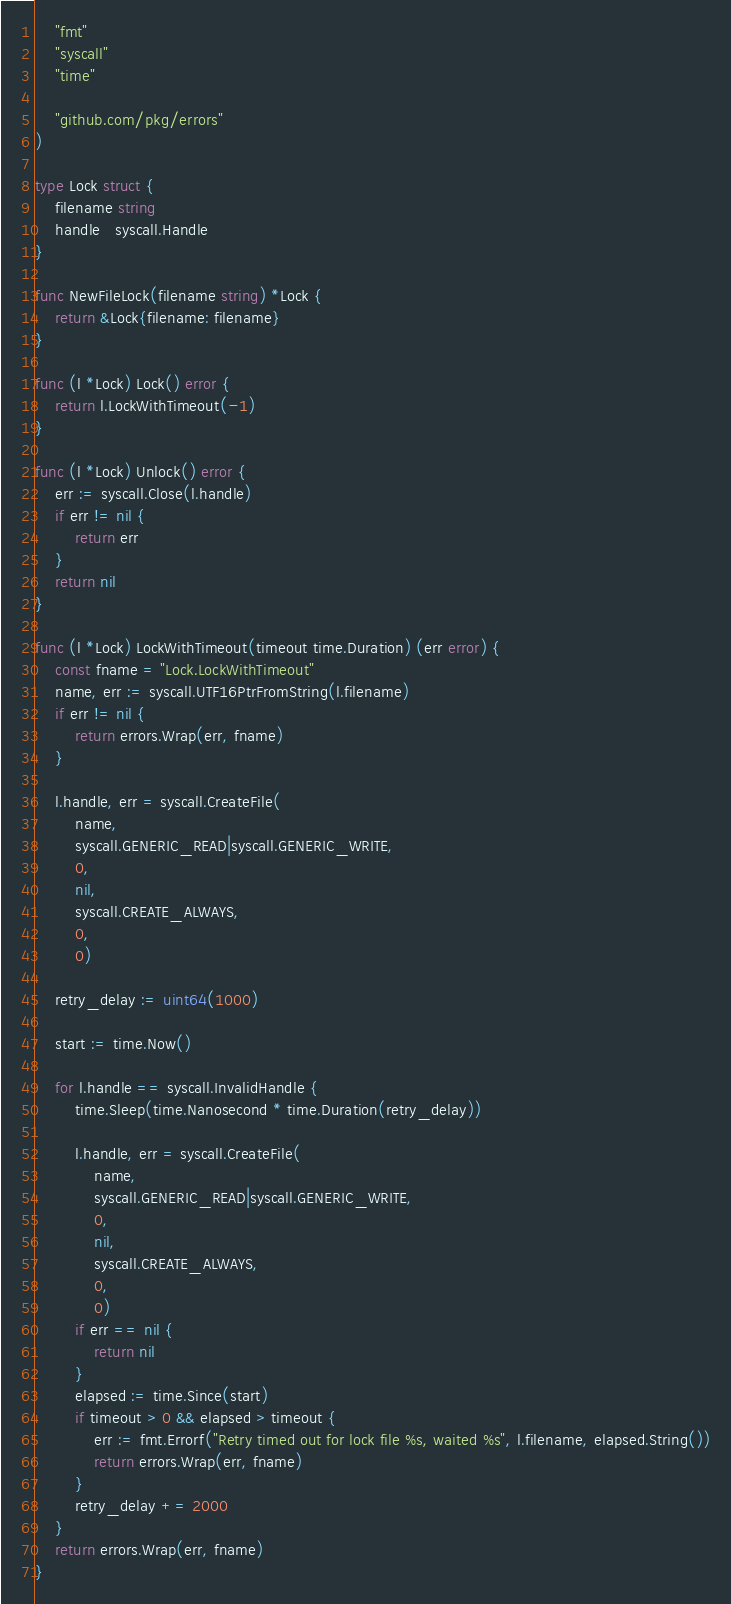<code> <loc_0><loc_0><loc_500><loc_500><_Go_>	"fmt"
	"syscall"
	"time"

	"github.com/pkg/errors"
)

type Lock struct {
	filename string
	handle   syscall.Handle
}

func NewFileLock(filename string) *Lock {
	return &Lock{filename: filename}
}

func (l *Lock) Lock() error {
	return l.LockWithTimeout(-1)
}

func (l *Lock) Unlock() error {
	err := syscall.Close(l.handle)
	if err != nil {
		return err
	}
	return nil
}

func (l *Lock) LockWithTimeout(timeout time.Duration) (err error) {
	const fname = "Lock.LockWithTimeout"
	name, err := syscall.UTF16PtrFromString(l.filename)
	if err != nil {
		return errors.Wrap(err, fname)
	}

	l.handle, err = syscall.CreateFile(
		name,
		syscall.GENERIC_READ|syscall.GENERIC_WRITE,
		0,
		nil,
		syscall.CREATE_ALWAYS,
		0,
		0)

	retry_delay := uint64(1000)

	start := time.Now()

	for l.handle == syscall.InvalidHandle {
		time.Sleep(time.Nanosecond * time.Duration(retry_delay))

		l.handle, err = syscall.CreateFile(
			name,
			syscall.GENERIC_READ|syscall.GENERIC_WRITE,
			0,
			nil,
			syscall.CREATE_ALWAYS,
			0,
			0)
		if err == nil {
			return nil
		}
		elapsed := time.Since(start)
		if timeout > 0 && elapsed > timeout {
			err := fmt.Errorf("Retry timed out for lock file %s, waited %s", l.filename, elapsed.String())
			return errors.Wrap(err, fname)
		}
		retry_delay += 2000
	}
	return errors.Wrap(err, fname)
}
</code> 